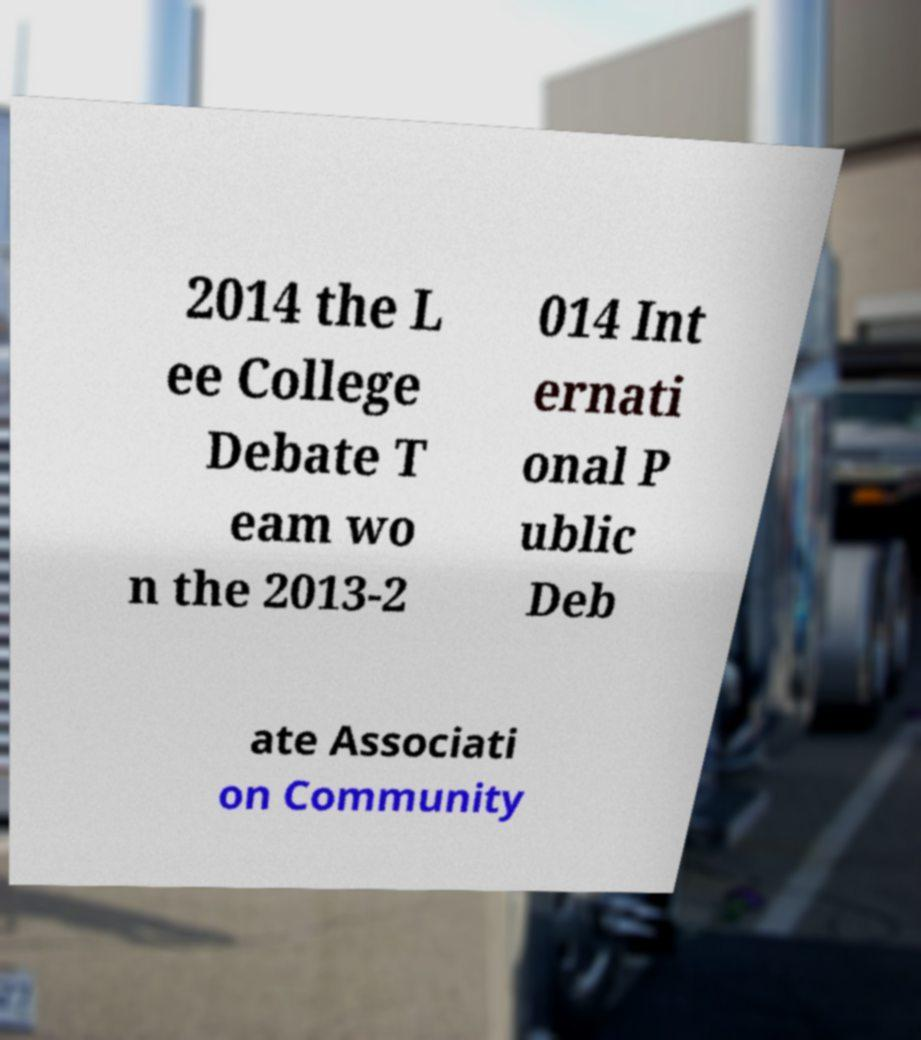For documentation purposes, I need the text within this image transcribed. Could you provide that? 2014 the L ee College Debate T eam wo n the 2013-2 014 Int ernati onal P ublic Deb ate Associati on Community 